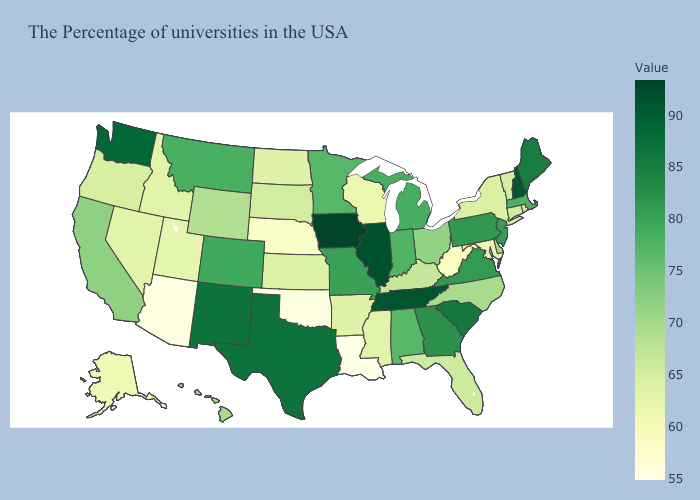Which states have the highest value in the USA?
Quick response, please. Iowa. Does Louisiana have the lowest value in the USA?
Answer briefly. Yes. Among the states that border Virginia , which have the highest value?
Quick response, please. Tennessee. Does Montana have a lower value than West Virginia?
Quick response, please. No. Among the states that border Illinois , does Indiana have the lowest value?
Give a very brief answer. No. 